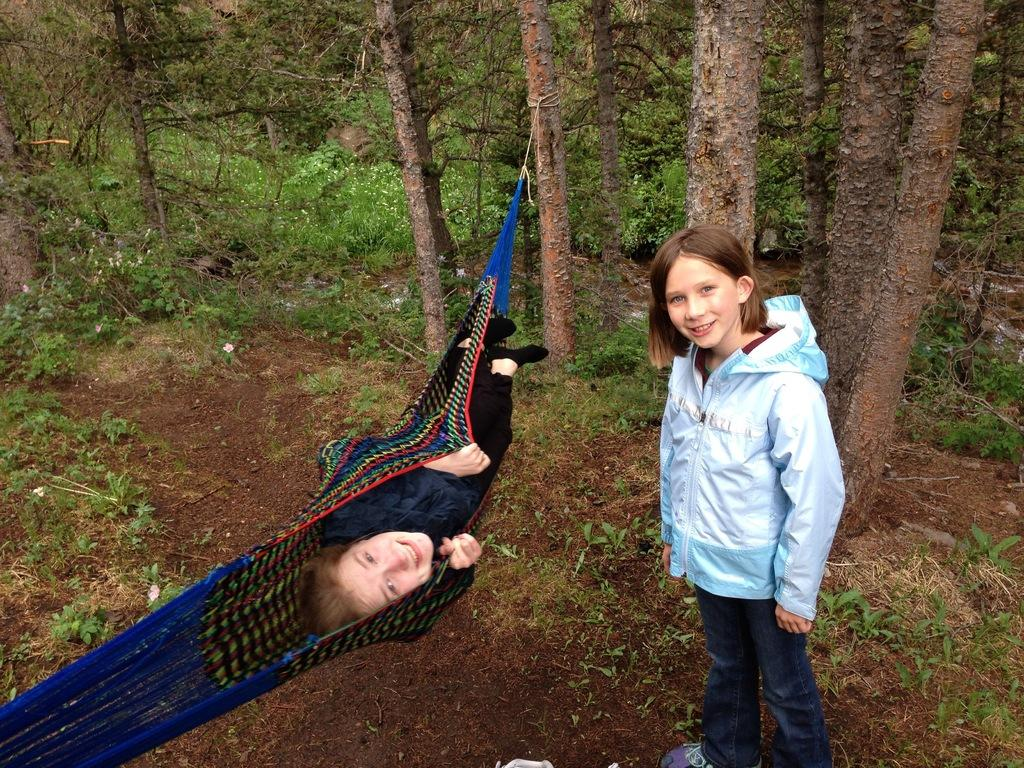What is the girl in the image doing? The girl is standing on the ground in the image. What is the girl's facial expression? The girl is smiling. What is the other person in the image doing? The person is lying on a swing in the image. What can be seen in the background of the image? Trees are visible in the background of the image. Why is the girl crying in the image? The girl is not crying in the image; she is smiling. What type of crook is present in the image? There is no crook present in the image. 